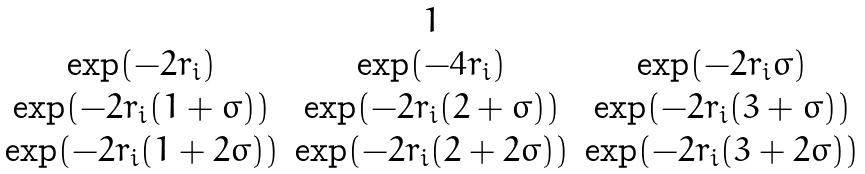Convert formula to latex. <formula><loc_0><loc_0><loc_500><loc_500>\begin{matrix} & 1 & \\ \exp ( - 2 r _ { i } ) & \exp ( - 4 r _ { i } ) & \exp ( - 2 r _ { i } \sigma ) \\ \exp ( - 2 r _ { i } ( 1 + \sigma ) ) & \exp ( - 2 r _ { i } ( 2 + \sigma ) ) & \exp ( - 2 r _ { i } ( 3 + \sigma ) ) \\ \exp ( - 2 r _ { i } ( 1 + 2 \sigma ) ) & \exp ( - 2 r _ { i } ( 2 + 2 \sigma ) ) & \exp ( - 2 r _ { i } ( 3 + 2 \sigma ) ) \end{matrix}</formula> 